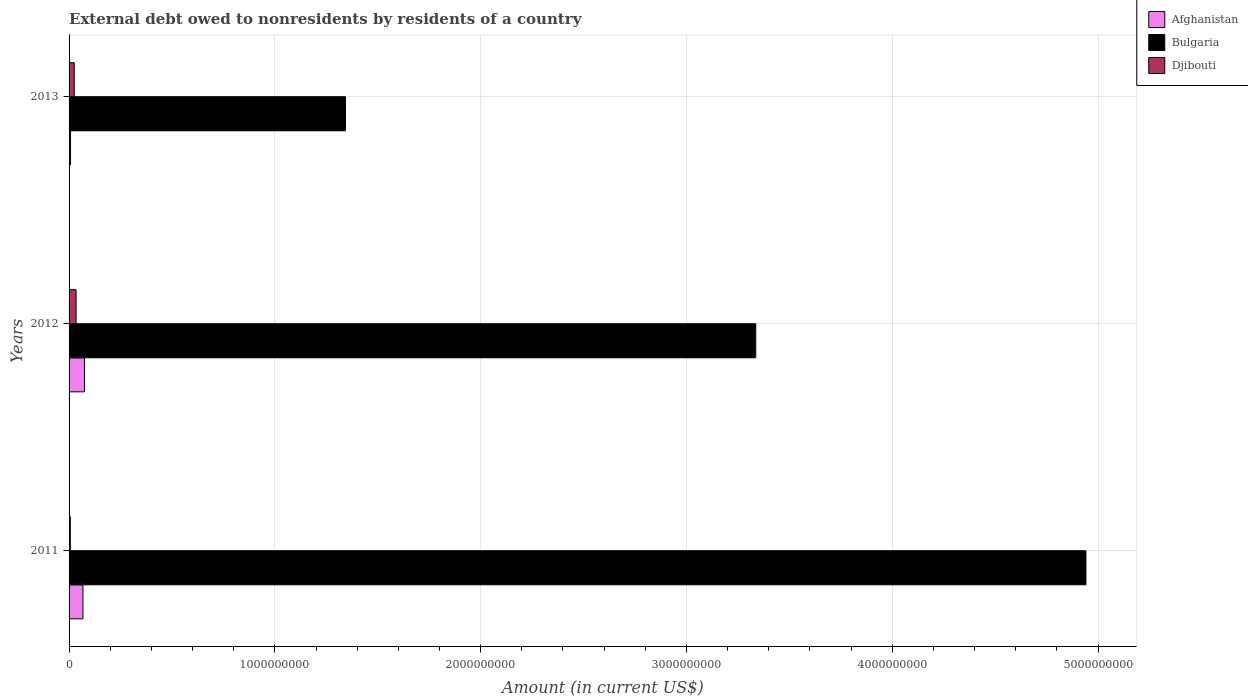Are the number of bars per tick equal to the number of legend labels?
Provide a succinct answer. Yes. How many bars are there on the 1st tick from the top?
Provide a succinct answer. 3. How many bars are there on the 3rd tick from the bottom?
Your response must be concise. 3. What is the label of the 2nd group of bars from the top?
Ensure brevity in your answer.  2012. What is the external debt owed by residents in Afghanistan in 2012?
Ensure brevity in your answer.  7.48e+07. Across all years, what is the maximum external debt owed by residents in Bulgaria?
Offer a very short reply. 4.94e+09. Across all years, what is the minimum external debt owed by residents in Afghanistan?
Keep it short and to the point. 7.14e+06. What is the total external debt owed by residents in Afghanistan in the graph?
Ensure brevity in your answer.  1.49e+08. What is the difference between the external debt owed by residents in Bulgaria in 2011 and that in 2013?
Provide a short and direct response. 3.60e+09. What is the difference between the external debt owed by residents in Djibouti in 2011 and the external debt owed by residents in Bulgaria in 2013?
Offer a very short reply. -1.34e+09. What is the average external debt owed by residents in Bulgaria per year?
Make the answer very short. 3.21e+09. In the year 2013, what is the difference between the external debt owed by residents in Djibouti and external debt owed by residents in Afghanistan?
Offer a terse response. 1.81e+07. In how many years, is the external debt owed by residents in Djibouti greater than 2400000000 US$?
Provide a succinct answer. 0. What is the ratio of the external debt owed by residents in Bulgaria in 2011 to that in 2013?
Keep it short and to the point. 3.68. Is the difference between the external debt owed by residents in Djibouti in 2011 and 2013 greater than the difference between the external debt owed by residents in Afghanistan in 2011 and 2013?
Keep it short and to the point. No. What is the difference between the highest and the second highest external debt owed by residents in Afghanistan?
Provide a succinct answer. 7.45e+06. What is the difference between the highest and the lowest external debt owed by residents in Djibouti?
Provide a succinct answer. 2.79e+07. In how many years, is the external debt owed by residents in Djibouti greater than the average external debt owed by residents in Djibouti taken over all years?
Your answer should be compact. 2. What does the 3rd bar from the top in 2013 represents?
Offer a very short reply. Afghanistan. What does the 1st bar from the bottom in 2011 represents?
Offer a terse response. Afghanistan. Is it the case that in every year, the sum of the external debt owed by residents in Bulgaria and external debt owed by residents in Afghanistan is greater than the external debt owed by residents in Djibouti?
Provide a succinct answer. Yes. Are all the bars in the graph horizontal?
Your response must be concise. Yes. How many years are there in the graph?
Ensure brevity in your answer.  3. What is the difference between two consecutive major ticks on the X-axis?
Your response must be concise. 1.00e+09. Are the values on the major ticks of X-axis written in scientific E-notation?
Make the answer very short. No. Does the graph contain grids?
Make the answer very short. Yes. How are the legend labels stacked?
Ensure brevity in your answer.  Vertical. What is the title of the graph?
Provide a succinct answer. External debt owed to nonresidents by residents of a country. What is the label or title of the X-axis?
Offer a terse response. Amount (in current US$). What is the label or title of the Y-axis?
Your answer should be compact. Years. What is the Amount (in current US$) of Afghanistan in 2011?
Your answer should be very brief. 6.73e+07. What is the Amount (in current US$) in Bulgaria in 2011?
Provide a short and direct response. 4.94e+09. What is the Amount (in current US$) of Djibouti in 2011?
Provide a succinct answer. 6.24e+06. What is the Amount (in current US$) of Afghanistan in 2012?
Keep it short and to the point. 7.48e+07. What is the Amount (in current US$) in Bulgaria in 2012?
Keep it short and to the point. 3.34e+09. What is the Amount (in current US$) in Djibouti in 2012?
Make the answer very short. 3.41e+07. What is the Amount (in current US$) of Afghanistan in 2013?
Your response must be concise. 7.14e+06. What is the Amount (in current US$) of Bulgaria in 2013?
Ensure brevity in your answer.  1.34e+09. What is the Amount (in current US$) of Djibouti in 2013?
Your answer should be very brief. 2.52e+07. Across all years, what is the maximum Amount (in current US$) of Afghanistan?
Your response must be concise. 7.48e+07. Across all years, what is the maximum Amount (in current US$) of Bulgaria?
Your answer should be very brief. 4.94e+09. Across all years, what is the maximum Amount (in current US$) of Djibouti?
Give a very brief answer. 3.41e+07. Across all years, what is the minimum Amount (in current US$) of Afghanistan?
Make the answer very short. 7.14e+06. Across all years, what is the minimum Amount (in current US$) in Bulgaria?
Your answer should be very brief. 1.34e+09. Across all years, what is the minimum Amount (in current US$) in Djibouti?
Provide a succinct answer. 6.24e+06. What is the total Amount (in current US$) of Afghanistan in the graph?
Keep it short and to the point. 1.49e+08. What is the total Amount (in current US$) of Bulgaria in the graph?
Your answer should be compact. 9.62e+09. What is the total Amount (in current US$) in Djibouti in the graph?
Keep it short and to the point. 6.56e+07. What is the difference between the Amount (in current US$) of Afghanistan in 2011 and that in 2012?
Provide a short and direct response. -7.45e+06. What is the difference between the Amount (in current US$) in Bulgaria in 2011 and that in 2012?
Provide a succinct answer. 1.60e+09. What is the difference between the Amount (in current US$) in Djibouti in 2011 and that in 2012?
Your response must be concise. -2.79e+07. What is the difference between the Amount (in current US$) of Afghanistan in 2011 and that in 2013?
Provide a succinct answer. 6.02e+07. What is the difference between the Amount (in current US$) of Bulgaria in 2011 and that in 2013?
Provide a short and direct response. 3.60e+09. What is the difference between the Amount (in current US$) of Djibouti in 2011 and that in 2013?
Keep it short and to the point. -1.90e+07. What is the difference between the Amount (in current US$) in Afghanistan in 2012 and that in 2013?
Give a very brief answer. 6.76e+07. What is the difference between the Amount (in current US$) in Bulgaria in 2012 and that in 2013?
Keep it short and to the point. 1.99e+09. What is the difference between the Amount (in current US$) in Djibouti in 2012 and that in 2013?
Give a very brief answer. 8.93e+06. What is the difference between the Amount (in current US$) in Afghanistan in 2011 and the Amount (in current US$) in Bulgaria in 2012?
Keep it short and to the point. -3.27e+09. What is the difference between the Amount (in current US$) of Afghanistan in 2011 and the Amount (in current US$) of Djibouti in 2012?
Offer a terse response. 3.32e+07. What is the difference between the Amount (in current US$) in Bulgaria in 2011 and the Amount (in current US$) in Djibouti in 2012?
Give a very brief answer. 4.91e+09. What is the difference between the Amount (in current US$) in Afghanistan in 2011 and the Amount (in current US$) in Bulgaria in 2013?
Provide a succinct answer. -1.28e+09. What is the difference between the Amount (in current US$) in Afghanistan in 2011 and the Amount (in current US$) in Djibouti in 2013?
Provide a succinct answer. 4.21e+07. What is the difference between the Amount (in current US$) of Bulgaria in 2011 and the Amount (in current US$) of Djibouti in 2013?
Keep it short and to the point. 4.92e+09. What is the difference between the Amount (in current US$) of Afghanistan in 2012 and the Amount (in current US$) of Bulgaria in 2013?
Give a very brief answer. -1.27e+09. What is the difference between the Amount (in current US$) of Afghanistan in 2012 and the Amount (in current US$) of Djibouti in 2013?
Offer a very short reply. 4.95e+07. What is the difference between the Amount (in current US$) in Bulgaria in 2012 and the Amount (in current US$) in Djibouti in 2013?
Your answer should be very brief. 3.31e+09. What is the average Amount (in current US$) in Afghanistan per year?
Your answer should be compact. 4.97e+07. What is the average Amount (in current US$) in Bulgaria per year?
Make the answer very short. 3.21e+09. What is the average Amount (in current US$) in Djibouti per year?
Ensure brevity in your answer.  2.19e+07. In the year 2011, what is the difference between the Amount (in current US$) of Afghanistan and Amount (in current US$) of Bulgaria?
Your response must be concise. -4.87e+09. In the year 2011, what is the difference between the Amount (in current US$) in Afghanistan and Amount (in current US$) in Djibouti?
Offer a terse response. 6.11e+07. In the year 2011, what is the difference between the Amount (in current US$) in Bulgaria and Amount (in current US$) in Djibouti?
Offer a very short reply. 4.93e+09. In the year 2012, what is the difference between the Amount (in current US$) of Afghanistan and Amount (in current US$) of Bulgaria?
Provide a short and direct response. -3.26e+09. In the year 2012, what is the difference between the Amount (in current US$) in Afghanistan and Amount (in current US$) in Djibouti?
Your answer should be compact. 4.06e+07. In the year 2012, what is the difference between the Amount (in current US$) in Bulgaria and Amount (in current US$) in Djibouti?
Your response must be concise. 3.30e+09. In the year 2013, what is the difference between the Amount (in current US$) in Afghanistan and Amount (in current US$) in Bulgaria?
Offer a terse response. -1.34e+09. In the year 2013, what is the difference between the Amount (in current US$) in Afghanistan and Amount (in current US$) in Djibouti?
Your answer should be compact. -1.81e+07. In the year 2013, what is the difference between the Amount (in current US$) in Bulgaria and Amount (in current US$) in Djibouti?
Your answer should be compact. 1.32e+09. What is the ratio of the Amount (in current US$) of Afghanistan in 2011 to that in 2012?
Your answer should be compact. 0.9. What is the ratio of the Amount (in current US$) in Bulgaria in 2011 to that in 2012?
Provide a succinct answer. 1.48. What is the ratio of the Amount (in current US$) of Djibouti in 2011 to that in 2012?
Your answer should be compact. 0.18. What is the ratio of the Amount (in current US$) in Afghanistan in 2011 to that in 2013?
Keep it short and to the point. 9.43. What is the ratio of the Amount (in current US$) of Bulgaria in 2011 to that in 2013?
Keep it short and to the point. 3.68. What is the ratio of the Amount (in current US$) of Djibouti in 2011 to that in 2013?
Offer a very short reply. 0.25. What is the ratio of the Amount (in current US$) in Afghanistan in 2012 to that in 2013?
Your response must be concise. 10.47. What is the ratio of the Amount (in current US$) in Bulgaria in 2012 to that in 2013?
Offer a very short reply. 2.48. What is the ratio of the Amount (in current US$) in Djibouti in 2012 to that in 2013?
Offer a very short reply. 1.35. What is the difference between the highest and the second highest Amount (in current US$) of Afghanistan?
Make the answer very short. 7.45e+06. What is the difference between the highest and the second highest Amount (in current US$) in Bulgaria?
Provide a short and direct response. 1.60e+09. What is the difference between the highest and the second highest Amount (in current US$) of Djibouti?
Your answer should be compact. 8.93e+06. What is the difference between the highest and the lowest Amount (in current US$) in Afghanistan?
Make the answer very short. 6.76e+07. What is the difference between the highest and the lowest Amount (in current US$) in Bulgaria?
Offer a very short reply. 3.60e+09. What is the difference between the highest and the lowest Amount (in current US$) in Djibouti?
Provide a short and direct response. 2.79e+07. 